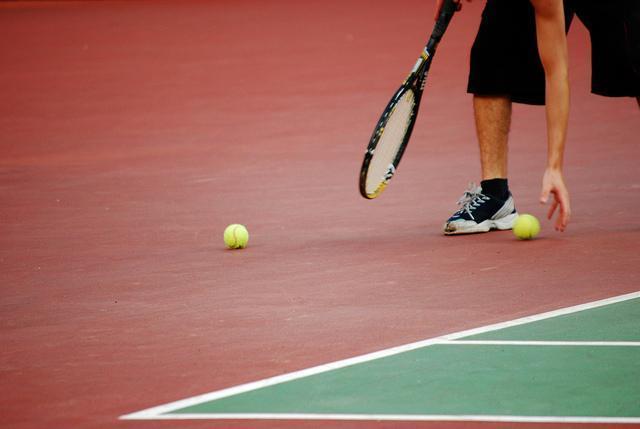How many balls are here?
Give a very brief answer. 2. How many suitcases are pictured?
Give a very brief answer. 0. 